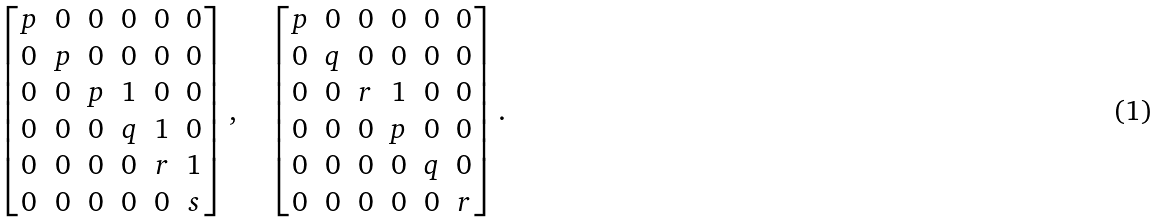<formula> <loc_0><loc_0><loc_500><loc_500>\left [ \begin{matrix} p & 0 & 0 & 0 & 0 & 0 \\ 0 & p & 0 & 0 & 0 & 0 \\ 0 & 0 & p & 1 & 0 & 0 \\ 0 & 0 & 0 & q & 1 & 0 \\ 0 & 0 & 0 & 0 & r & 1 \\ 0 & 0 & 0 & 0 & 0 & s \end{matrix} \right ] , \quad \left [ \begin{matrix} p & 0 & 0 & 0 & 0 & 0 \\ 0 & q & 0 & 0 & 0 & 0 \\ 0 & 0 & r & 1 & 0 & 0 \\ 0 & 0 & 0 & p & 0 & 0 \\ 0 & 0 & 0 & 0 & q & 0 \\ 0 & 0 & 0 & 0 & 0 & r \end{matrix} \right ] .</formula> 